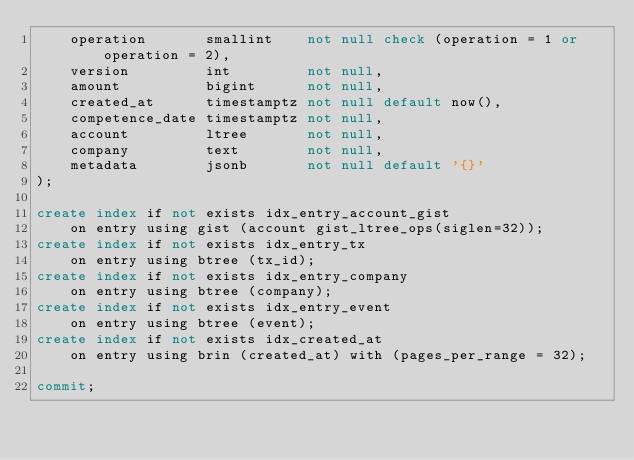Convert code to text. <code><loc_0><loc_0><loc_500><loc_500><_SQL_>    operation       smallint    not null check (operation = 1 or operation = 2),
    version         int         not null,
    amount          bigint      not null,
    created_at      timestamptz not null default now(),
    competence_date timestamptz not null,
    account         ltree       not null,
    company         text        not null,
    metadata        jsonb       not null default '{}'
);

create index if not exists idx_entry_account_gist
    on entry using gist (account gist_ltree_ops(siglen=32));
create index if not exists idx_entry_tx
    on entry using btree (tx_id);
create index if not exists idx_entry_company
    on entry using btree (company);
create index if not exists idx_entry_event
    on entry using btree (event);
create index if not exists idx_created_at
    on entry using brin (created_at) with (pages_per_range = 32);

commit;
</code> 